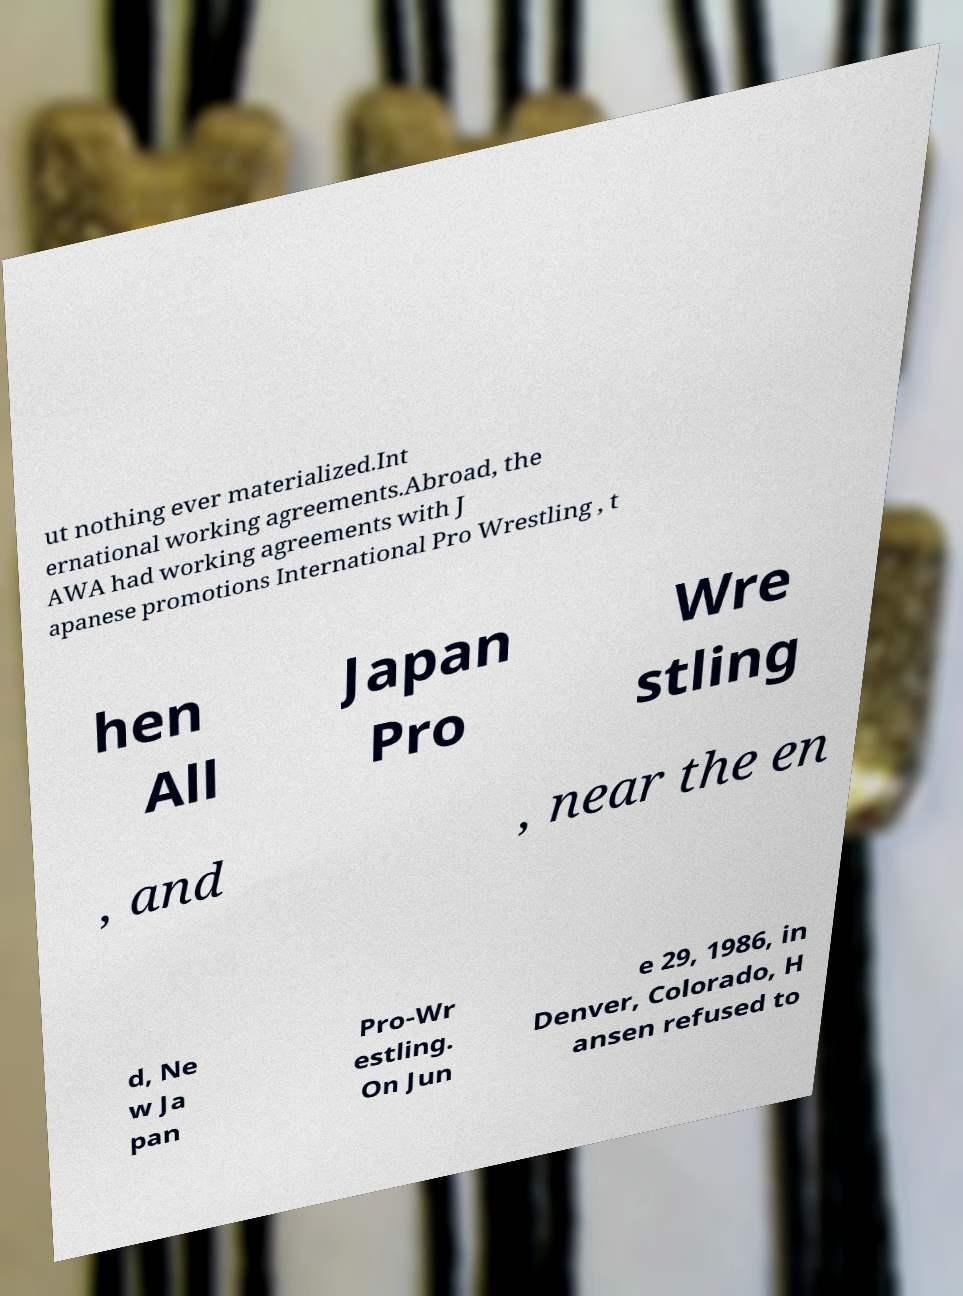Could you extract and type out the text from this image? ut nothing ever materialized.Int ernational working agreements.Abroad, the AWA had working agreements with J apanese promotions International Pro Wrestling , t hen All Japan Pro Wre stling , and , near the en d, Ne w Ja pan Pro-Wr estling. On Jun e 29, 1986, in Denver, Colorado, H ansen refused to 